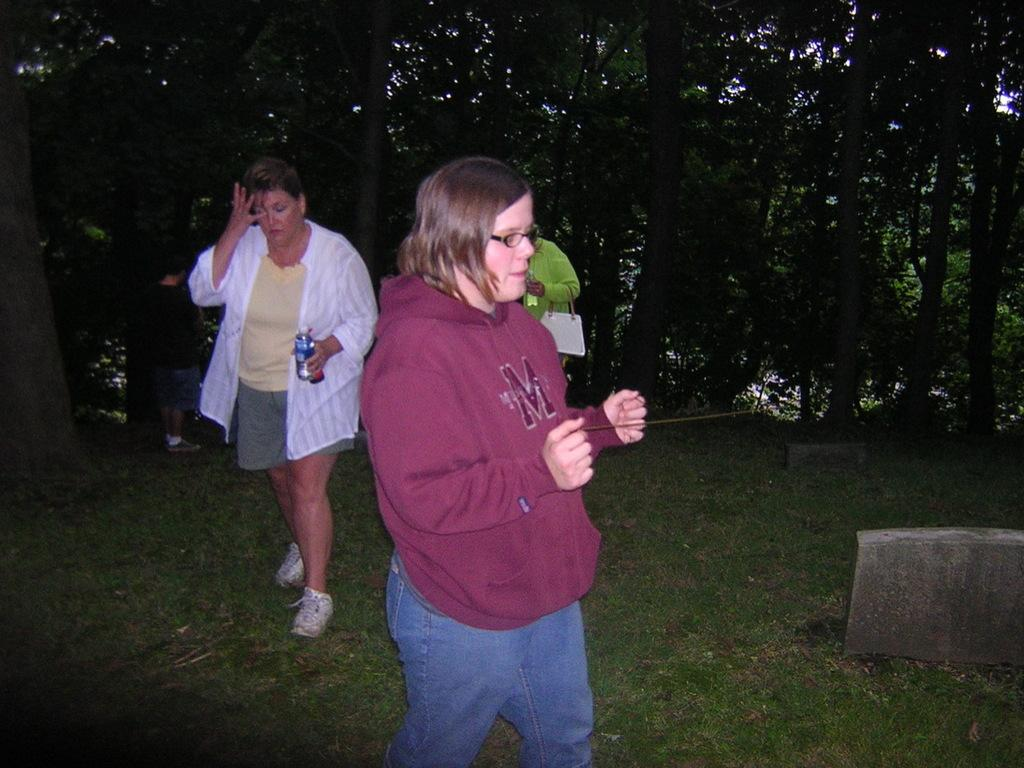What are the people in the image doing? The people in the image are standing on the ground. What is the woman holding in the image? The woman is holding a tin in the image. What is the other person carrying in the image? The other person is carrying a bag in the image. What type of vegetation can be seen in the image? There is grass visible in the image. What can be seen in the background of the image? There is a group of trees in the image. What type of punishment is being given to the people in the image? There is no indication of punishment in the image; the people are simply standing on the ground. How much debt is visible in the image? There is no mention of debt in the image; it focuses on people standing on the ground and holding or carrying various items. 